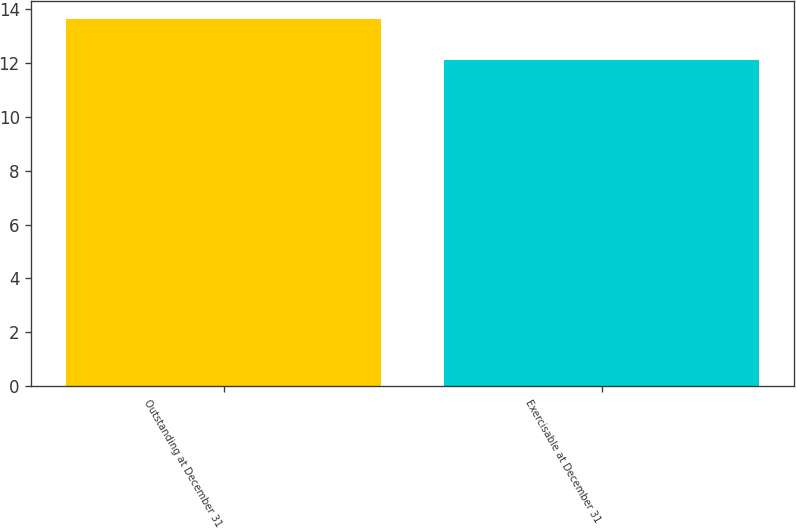Convert chart. <chart><loc_0><loc_0><loc_500><loc_500><bar_chart><fcel>Outstanding at December 31<fcel>Exercisable at December 31<nl><fcel>13.62<fcel>12.1<nl></chart> 